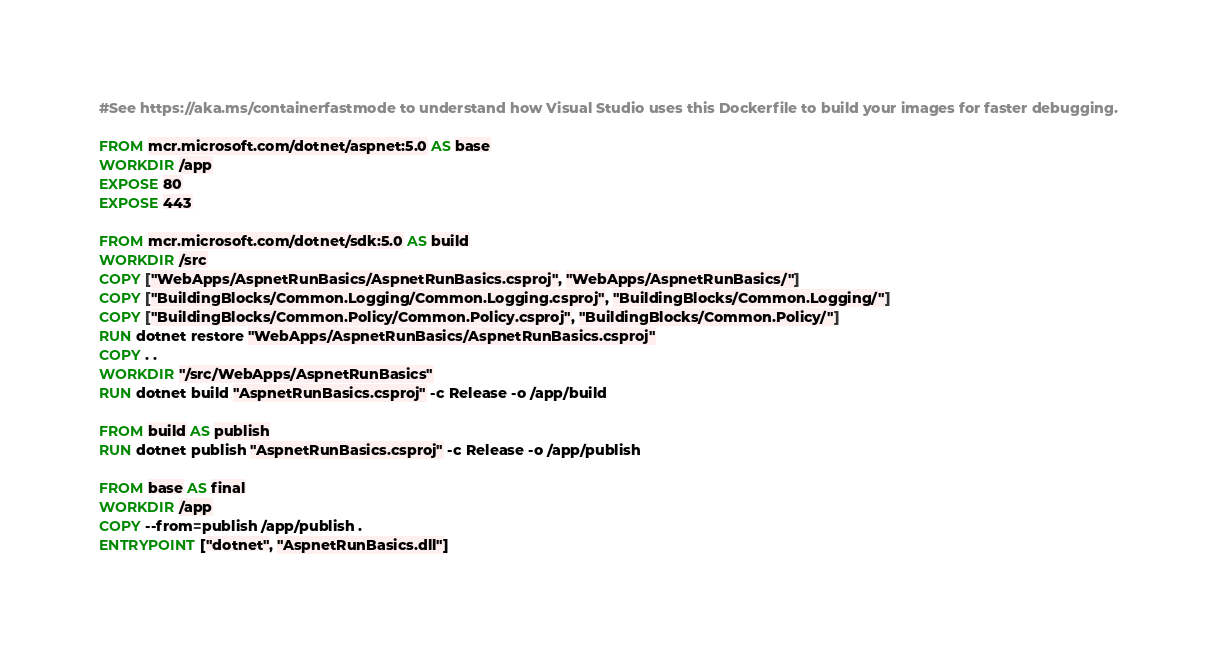Convert code to text. <code><loc_0><loc_0><loc_500><loc_500><_Dockerfile_>#See https://aka.ms/containerfastmode to understand how Visual Studio uses this Dockerfile to build your images for faster debugging.

FROM mcr.microsoft.com/dotnet/aspnet:5.0 AS base
WORKDIR /app
EXPOSE 80
EXPOSE 443

FROM mcr.microsoft.com/dotnet/sdk:5.0 AS build
WORKDIR /src
COPY ["WebApps/AspnetRunBasics/AspnetRunBasics.csproj", "WebApps/AspnetRunBasics/"]
COPY ["BuildingBlocks/Common.Logging/Common.Logging.csproj", "BuildingBlocks/Common.Logging/"]
COPY ["BuildingBlocks/Common.Policy/Common.Policy.csproj", "BuildingBlocks/Common.Policy/"]
RUN dotnet restore "WebApps/AspnetRunBasics/AspnetRunBasics.csproj"
COPY . .
WORKDIR "/src/WebApps/AspnetRunBasics"
RUN dotnet build "AspnetRunBasics.csproj" -c Release -o /app/build

FROM build AS publish
RUN dotnet publish "AspnetRunBasics.csproj" -c Release -o /app/publish

FROM base AS final
WORKDIR /app
COPY --from=publish /app/publish .
ENTRYPOINT ["dotnet", "AspnetRunBasics.dll"]</code> 